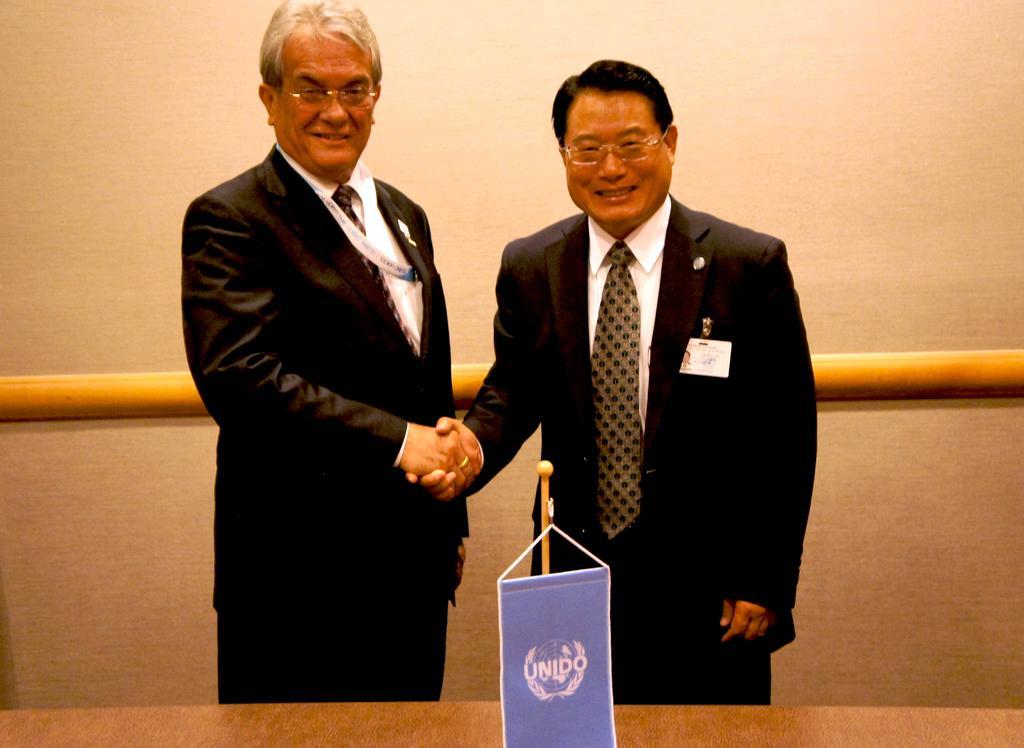Could you give a brief overview of what you see in this image? In this image in the center there are two persons who are standing and they are shaking hands with each other, in the background there is a wall and pipe. At the bottom there is one board and table. 